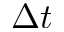Convert formula to latex. <formula><loc_0><loc_0><loc_500><loc_500>\Delta t</formula> 